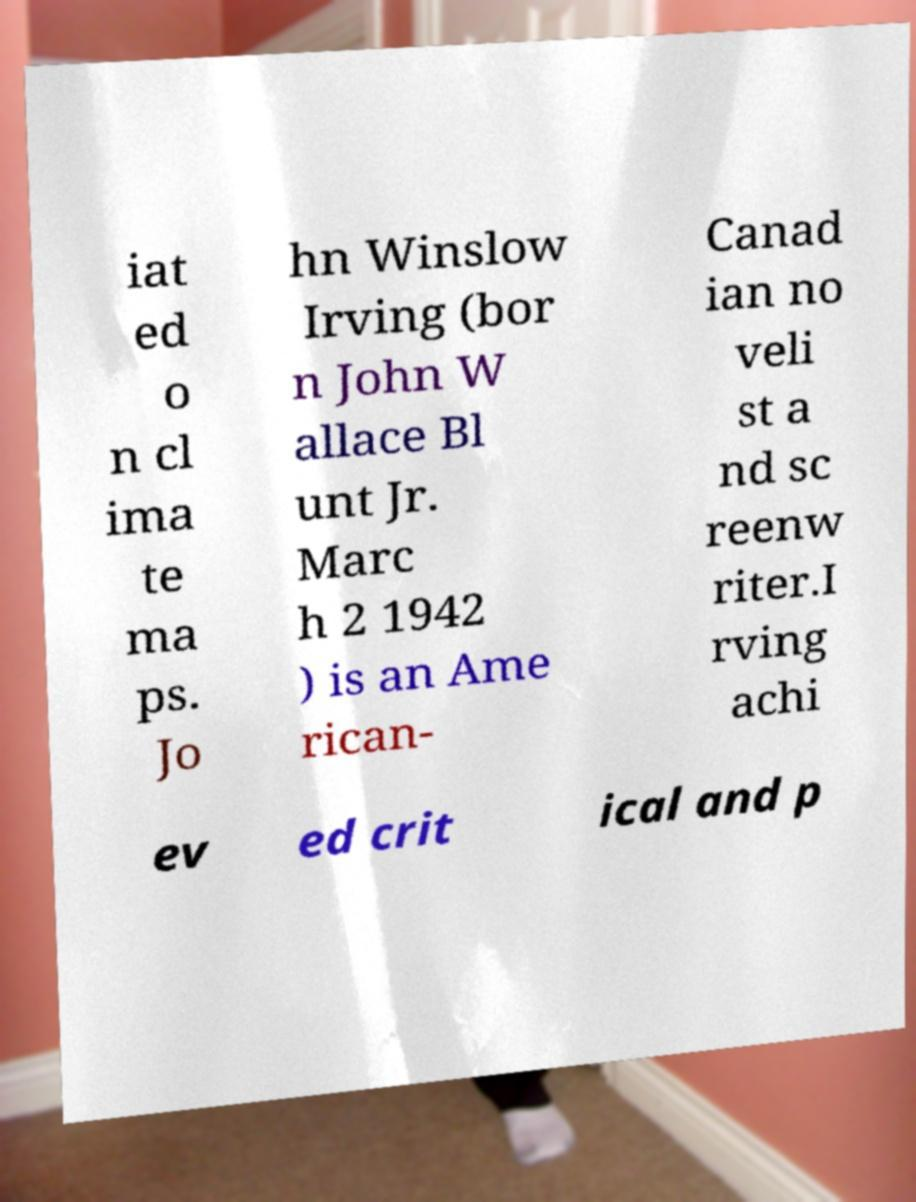Can you accurately transcribe the text from the provided image for me? iat ed o n cl ima te ma ps. Jo hn Winslow Irving (bor n John W allace Bl unt Jr. Marc h 2 1942 ) is an Ame rican- Canad ian no veli st a nd sc reenw riter.I rving achi ev ed crit ical and p 